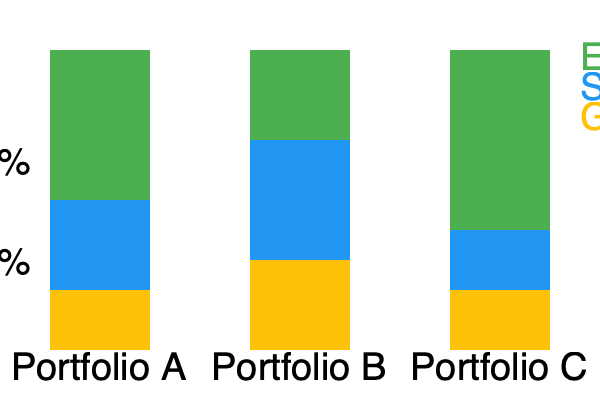Based on the stacked bar chart comparing the social impact of three investment portfolios (A, B, and C) across Environmental, Social, and Governance (ESG) factors, which portfolio would be most aligned with the values of an investor primarily concerned with environmental impact? To determine which portfolio is most aligned with an investor primarily concerned with environmental impact, we need to analyze the proportion of each portfolio dedicated to environmental factors:

1. Identify the environmental component:
   The green (top) section of each bar represents the environmental factor.

2. Compare environmental proportions:
   Portfolio A: 50% (150px / 300px)
   Portfolio B: 30% (90px / 300px)
   Portfolio C: 60% (180px / 300px)

3. Rank portfolios based on environmental focus:
   1. Portfolio C (60%)
   2. Portfolio A (50%)
   3. Portfolio B (30%)

4. Consider other factors:
   While Portfolio C has the highest environmental focus, it's important to note that it has the lowest allocation to social factors. However, since the question specifies primary concern with environmental impact, this is less relevant.

5. Conclusion:
   Portfolio C has the highest proportion (60%) dedicated to environmental factors, making it the most aligned with an investor primarily concerned with environmental impact.
Answer: Portfolio C 